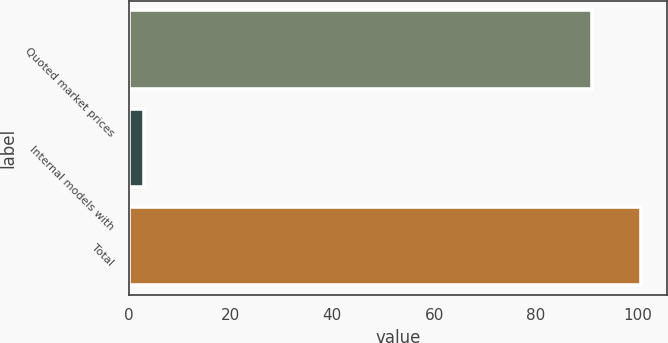Convert chart. <chart><loc_0><loc_0><loc_500><loc_500><bar_chart><fcel>Quoted market prices<fcel>Internal models with<fcel>Total<nl><fcel>91<fcel>3<fcel>100.7<nl></chart> 